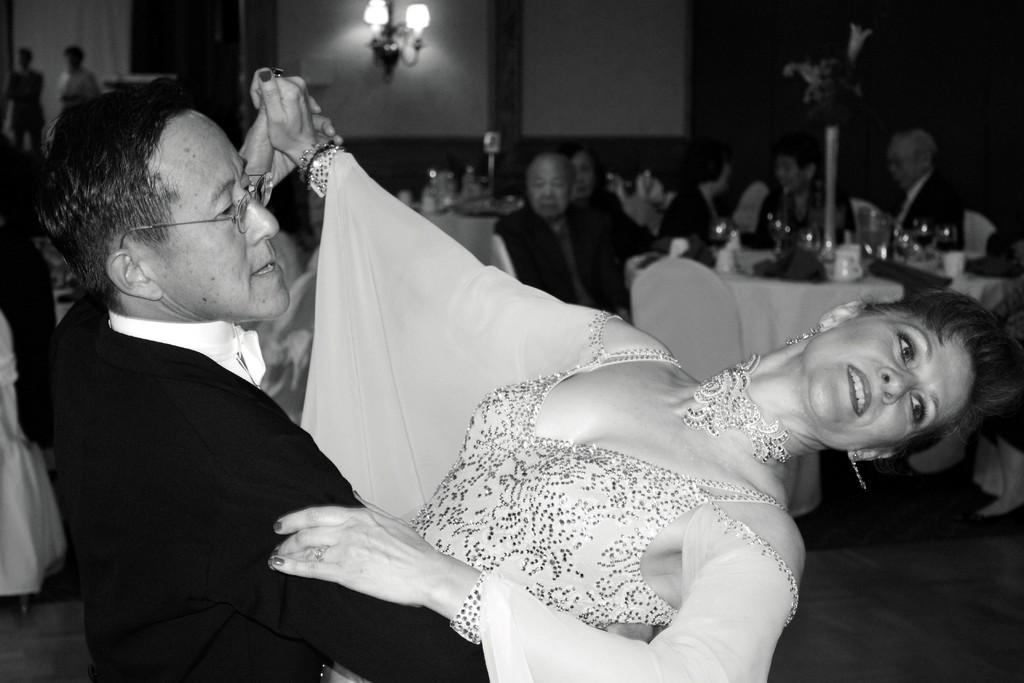Who can be seen in the image? There is an old man and an old woman in the image. What are the old man and old woman doing? The old man and old woman are dancing. Are there any other people in the image? Yes, there are people sitting in the background of the image. What type of star can be seen in the sky in the image? There is no star visible in the image, nor is there any sky shown. 